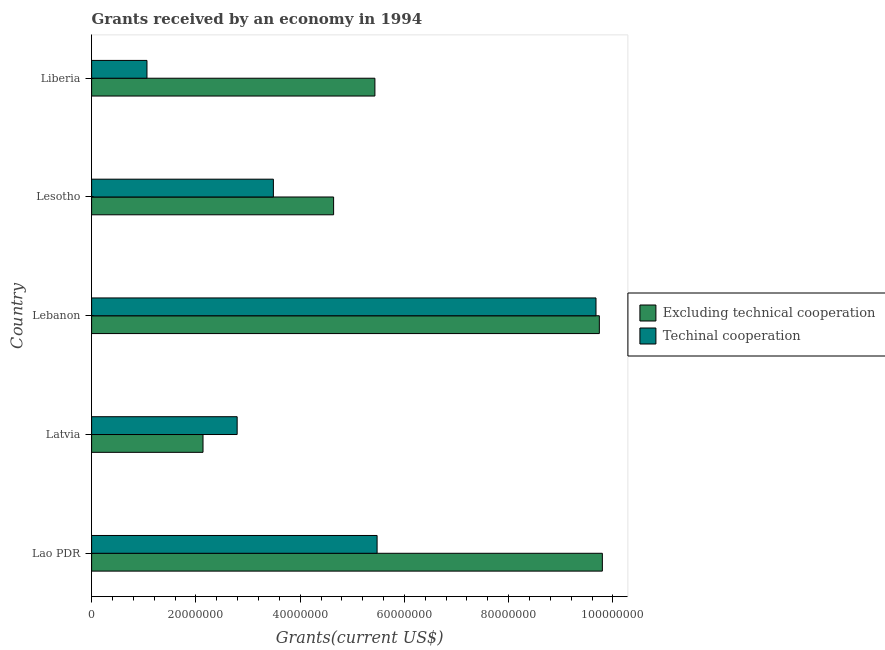How many groups of bars are there?
Ensure brevity in your answer.  5. Are the number of bars on each tick of the Y-axis equal?
Keep it short and to the point. Yes. How many bars are there on the 5th tick from the bottom?
Give a very brief answer. 2. What is the label of the 3rd group of bars from the top?
Provide a succinct answer. Lebanon. What is the amount of grants received(including technical cooperation) in Liberia?
Your response must be concise. 1.06e+07. Across all countries, what is the maximum amount of grants received(excluding technical cooperation)?
Your answer should be compact. 9.80e+07. Across all countries, what is the minimum amount of grants received(including technical cooperation)?
Offer a terse response. 1.06e+07. In which country was the amount of grants received(including technical cooperation) maximum?
Make the answer very short. Lebanon. In which country was the amount of grants received(excluding technical cooperation) minimum?
Offer a very short reply. Latvia. What is the total amount of grants received(excluding technical cooperation) in the graph?
Offer a terse response. 3.17e+08. What is the difference between the amount of grants received(including technical cooperation) in Latvia and that in Lesotho?
Provide a succinct answer. -6.95e+06. What is the difference between the amount of grants received(excluding technical cooperation) in Lesotho and the amount of grants received(including technical cooperation) in Lao PDR?
Provide a short and direct response. -8.34e+06. What is the average amount of grants received(including technical cooperation) per country?
Give a very brief answer. 4.50e+07. What is the difference between the amount of grants received(excluding technical cooperation) and amount of grants received(including technical cooperation) in Lao PDR?
Offer a very short reply. 4.32e+07. In how many countries, is the amount of grants received(including technical cooperation) greater than 28000000 US$?
Your answer should be very brief. 3. What is the ratio of the amount of grants received(including technical cooperation) in Latvia to that in Liberia?
Offer a very short reply. 2.63. Is the difference between the amount of grants received(including technical cooperation) in Lao PDR and Lesotho greater than the difference between the amount of grants received(excluding technical cooperation) in Lao PDR and Lesotho?
Offer a terse response. No. What is the difference between the highest and the second highest amount of grants received(including technical cooperation)?
Make the answer very short. 4.20e+07. What is the difference between the highest and the lowest amount of grants received(including technical cooperation)?
Keep it short and to the point. 8.61e+07. In how many countries, is the amount of grants received(including technical cooperation) greater than the average amount of grants received(including technical cooperation) taken over all countries?
Make the answer very short. 2. Is the sum of the amount of grants received(including technical cooperation) in Latvia and Lebanon greater than the maximum amount of grants received(excluding technical cooperation) across all countries?
Offer a very short reply. Yes. What does the 1st bar from the top in Liberia represents?
Give a very brief answer. Techinal cooperation. What does the 1st bar from the bottom in Lebanon represents?
Keep it short and to the point. Excluding technical cooperation. Are all the bars in the graph horizontal?
Offer a terse response. Yes. Are the values on the major ticks of X-axis written in scientific E-notation?
Offer a very short reply. No. Does the graph contain grids?
Make the answer very short. No. How are the legend labels stacked?
Ensure brevity in your answer.  Vertical. What is the title of the graph?
Offer a terse response. Grants received by an economy in 1994. Does "Goods" appear as one of the legend labels in the graph?
Offer a very short reply. No. What is the label or title of the X-axis?
Your answer should be compact. Grants(current US$). What is the Grants(current US$) of Excluding technical cooperation in Lao PDR?
Your response must be concise. 9.80e+07. What is the Grants(current US$) of Techinal cooperation in Lao PDR?
Your answer should be compact. 5.48e+07. What is the Grants(current US$) in Excluding technical cooperation in Latvia?
Offer a very short reply. 2.14e+07. What is the Grants(current US$) of Techinal cooperation in Latvia?
Provide a short and direct response. 2.79e+07. What is the Grants(current US$) of Excluding technical cooperation in Lebanon?
Provide a short and direct response. 9.74e+07. What is the Grants(current US$) of Techinal cooperation in Lebanon?
Your answer should be very brief. 9.68e+07. What is the Grants(current US$) of Excluding technical cooperation in Lesotho?
Provide a short and direct response. 4.64e+07. What is the Grants(current US$) of Techinal cooperation in Lesotho?
Offer a terse response. 3.49e+07. What is the Grants(current US$) of Excluding technical cooperation in Liberia?
Make the answer very short. 5.43e+07. What is the Grants(current US$) in Techinal cooperation in Liberia?
Make the answer very short. 1.06e+07. Across all countries, what is the maximum Grants(current US$) in Excluding technical cooperation?
Make the answer very short. 9.80e+07. Across all countries, what is the maximum Grants(current US$) in Techinal cooperation?
Offer a very short reply. 9.68e+07. Across all countries, what is the minimum Grants(current US$) in Excluding technical cooperation?
Ensure brevity in your answer.  2.14e+07. Across all countries, what is the minimum Grants(current US$) of Techinal cooperation?
Your answer should be compact. 1.06e+07. What is the total Grants(current US$) in Excluding technical cooperation in the graph?
Ensure brevity in your answer.  3.17e+08. What is the total Grants(current US$) of Techinal cooperation in the graph?
Make the answer very short. 2.25e+08. What is the difference between the Grants(current US$) in Excluding technical cooperation in Lao PDR and that in Latvia?
Make the answer very short. 7.66e+07. What is the difference between the Grants(current US$) in Techinal cooperation in Lao PDR and that in Latvia?
Ensure brevity in your answer.  2.68e+07. What is the difference between the Grants(current US$) in Excluding technical cooperation in Lao PDR and that in Lebanon?
Keep it short and to the point. 5.80e+05. What is the difference between the Grants(current US$) in Techinal cooperation in Lao PDR and that in Lebanon?
Your response must be concise. -4.20e+07. What is the difference between the Grants(current US$) in Excluding technical cooperation in Lao PDR and that in Lesotho?
Your answer should be very brief. 5.16e+07. What is the difference between the Grants(current US$) of Techinal cooperation in Lao PDR and that in Lesotho?
Make the answer very short. 1.99e+07. What is the difference between the Grants(current US$) of Excluding technical cooperation in Lao PDR and that in Liberia?
Make the answer very short. 4.36e+07. What is the difference between the Grants(current US$) in Techinal cooperation in Lao PDR and that in Liberia?
Provide a succinct answer. 4.41e+07. What is the difference between the Grants(current US$) in Excluding technical cooperation in Latvia and that in Lebanon?
Your answer should be very brief. -7.60e+07. What is the difference between the Grants(current US$) in Techinal cooperation in Latvia and that in Lebanon?
Offer a very short reply. -6.88e+07. What is the difference between the Grants(current US$) in Excluding technical cooperation in Latvia and that in Lesotho?
Keep it short and to the point. -2.50e+07. What is the difference between the Grants(current US$) in Techinal cooperation in Latvia and that in Lesotho?
Provide a short and direct response. -6.95e+06. What is the difference between the Grants(current US$) in Excluding technical cooperation in Latvia and that in Liberia?
Offer a very short reply. -3.30e+07. What is the difference between the Grants(current US$) in Techinal cooperation in Latvia and that in Liberia?
Ensure brevity in your answer.  1.73e+07. What is the difference between the Grants(current US$) of Excluding technical cooperation in Lebanon and that in Lesotho?
Offer a terse response. 5.10e+07. What is the difference between the Grants(current US$) of Techinal cooperation in Lebanon and that in Lesotho?
Your answer should be very brief. 6.19e+07. What is the difference between the Grants(current US$) of Excluding technical cooperation in Lebanon and that in Liberia?
Offer a very short reply. 4.30e+07. What is the difference between the Grants(current US$) of Techinal cooperation in Lebanon and that in Liberia?
Give a very brief answer. 8.61e+07. What is the difference between the Grants(current US$) of Excluding technical cooperation in Lesotho and that in Liberia?
Provide a succinct answer. -7.92e+06. What is the difference between the Grants(current US$) in Techinal cooperation in Lesotho and that in Liberia?
Your answer should be very brief. 2.42e+07. What is the difference between the Grants(current US$) of Excluding technical cooperation in Lao PDR and the Grants(current US$) of Techinal cooperation in Latvia?
Your answer should be very brief. 7.00e+07. What is the difference between the Grants(current US$) of Excluding technical cooperation in Lao PDR and the Grants(current US$) of Techinal cooperation in Lebanon?
Provide a succinct answer. 1.22e+06. What is the difference between the Grants(current US$) in Excluding technical cooperation in Lao PDR and the Grants(current US$) in Techinal cooperation in Lesotho?
Provide a short and direct response. 6.31e+07. What is the difference between the Grants(current US$) of Excluding technical cooperation in Lao PDR and the Grants(current US$) of Techinal cooperation in Liberia?
Make the answer very short. 8.74e+07. What is the difference between the Grants(current US$) of Excluding technical cooperation in Latvia and the Grants(current US$) of Techinal cooperation in Lebanon?
Give a very brief answer. -7.54e+07. What is the difference between the Grants(current US$) of Excluding technical cooperation in Latvia and the Grants(current US$) of Techinal cooperation in Lesotho?
Make the answer very short. -1.35e+07. What is the difference between the Grants(current US$) of Excluding technical cooperation in Latvia and the Grants(current US$) of Techinal cooperation in Liberia?
Provide a succinct answer. 1.08e+07. What is the difference between the Grants(current US$) of Excluding technical cooperation in Lebanon and the Grants(current US$) of Techinal cooperation in Lesotho?
Offer a terse response. 6.25e+07. What is the difference between the Grants(current US$) in Excluding technical cooperation in Lebanon and the Grants(current US$) in Techinal cooperation in Liberia?
Give a very brief answer. 8.68e+07. What is the difference between the Grants(current US$) of Excluding technical cooperation in Lesotho and the Grants(current US$) of Techinal cooperation in Liberia?
Offer a very short reply. 3.58e+07. What is the average Grants(current US$) of Excluding technical cooperation per country?
Your answer should be compact. 6.35e+07. What is the average Grants(current US$) of Techinal cooperation per country?
Your answer should be compact. 4.50e+07. What is the difference between the Grants(current US$) in Excluding technical cooperation and Grants(current US$) in Techinal cooperation in Lao PDR?
Offer a very short reply. 4.32e+07. What is the difference between the Grants(current US$) in Excluding technical cooperation and Grants(current US$) in Techinal cooperation in Latvia?
Your answer should be compact. -6.55e+06. What is the difference between the Grants(current US$) of Excluding technical cooperation and Grants(current US$) of Techinal cooperation in Lebanon?
Ensure brevity in your answer.  6.40e+05. What is the difference between the Grants(current US$) in Excluding technical cooperation and Grants(current US$) in Techinal cooperation in Lesotho?
Ensure brevity in your answer.  1.16e+07. What is the difference between the Grants(current US$) of Excluding technical cooperation and Grants(current US$) of Techinal cooperation in Liberia?
Offer a very short reply. 4.37e+07. What is the ratio of the Grants(current US$) of Excluding technical cooperation in Lao PDR to that in Latvia?
Give a very brief answer. 4.58. What is the ratio of the Grants(current US$) in Techinal cooperation in Lao PDR to that in Latvia?
Give a very brief answer. 1.96. What is the ratio of the Grants(current US$) in Excluding technical cooperation in Lao PDR to that in Lebanon?
Your answer should be compact. 1.01. What is the ratio of the Grants(current US$) of Techinal cooperation in Lao PDR to that in Lebanon?
Make the answer very short. 0.57. What is the ratio of the Grants(current US$) in Excluding technical cooperation in Lao PDR to that in Lesotho?
Make the answer very short. 2.11. What is the ratio of the Grants(current US$) in Techinal cooperation in Lao PDR to that in Lesotho?
Your answer should be compact. 1.57. What is the ratio of the Grants(current US$) of Excluding technical cooperation in Lao PDR to that in Liberia?
Offer a terse response. 1.8. What is the ratio of the Grants(current US$) in Techinal cooperation in Lao PDR to that in Liberia?
Ensure brevity in your answer.  5.16. What is the ratio of the Grants(current US$) in Excluding technical cooperation in Latvia to that in Lebanon?
Offer a terse response. 0.22. What is the ratio of the Grants(current US$) of Techinal cooperation in Latvia to that in Lebanon?
Provide a short and direct response. 0.29. What is the ratio of the Grants(current US$) in Excluding technical cooperation in Latvia to that in Lesotho?
Offer a very short reply. 0.46. What is the ratio of the Grants(current US$) in Techinal cooperation in Latvia to that in Lesotho?
Keep it short and to the point. 0.8. What is the ratio of the Grants(current US$) of Excluding technical cooperation in Latvia to that in Liberia?
Your response must be concise. 0.39. What is the ratio of the Grants(current US$) of Techinal cooperation in Latvia to that in Liberia?
Your response must be concise. 2.63. What is the ratio of the Grants(current US$) in Excluding technical cooperation in Lebanon to that in Lesotho?
Provide a succinct answer. 2.1. What is the ratio of the Grants(current US$) in Techinal cooperation in Lebanon to that in Lesotho?
Make the answer very short. 2.77. What is the ratio of the Grants(current US$) of Excluding technical cooperation in Lebanon to that in Liberia?
Provide a short and direct response. 1.79. What is the ratio of the Grants(current US$) of Techinal cooperation in Lebanon to that in Liberia?
Your response must be concise. 9.11. What is the ratio of the Grants(current US$) of Excluding technical cooperation in Lesotho to that in Liberia?
Provide a succinct answer. 0.85. What is the ratio of the Grants(current US$) of Techinal cooperation in Lesotho to that in Liberia?
Your answer should be compact. 3.28. What is the difference between the highest and the second highest Grants(current US$) in Excluding technical cooperation?
Ensure brevity in your answer.  5.80e+05. What is the difference between the highest and the second highest Grants(current US$) in Techinal cooperation?
Give a very brief answer. 4.20e+07. What is the difference between the highest and the lowest Grants(current US$) of Excluding technical cooperation?
Provide a succinct answer. 7.66e+07. What is the difference between the highest and the lowest Grants(current US$) of Techinal cooperation?
Your answer should be compact. 8.61e+07. 